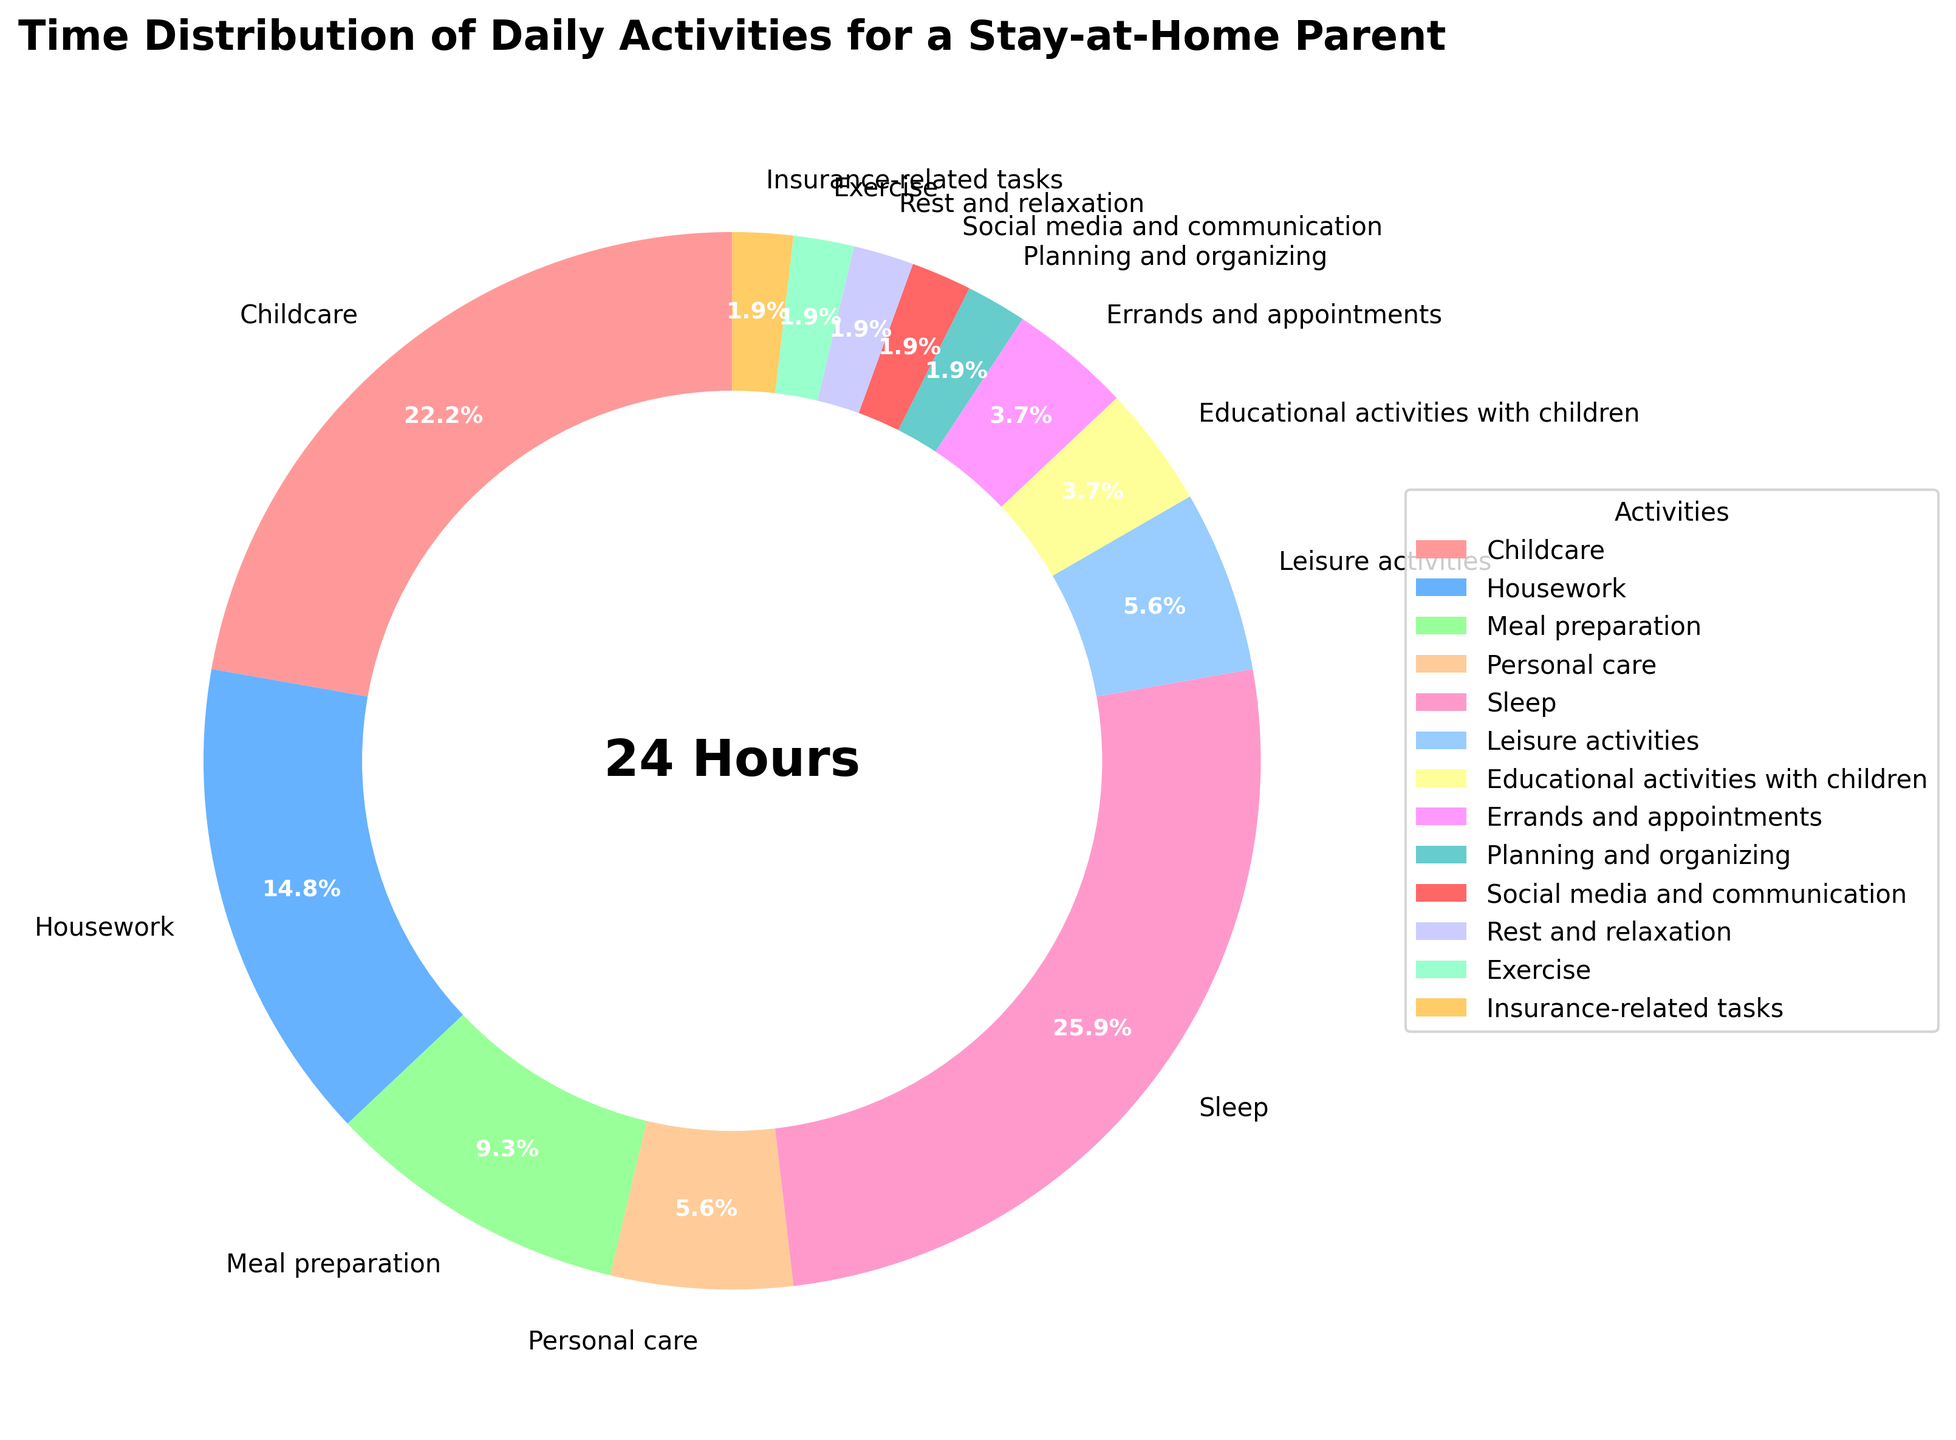which activity takes up the most hours in a day? The chart shows the percentage of time spent on each activity. The segment with the largest portion of the pie corresponds to the activity with the most hours. In this case, 'Sleep' occupies the most hours in a day.
Answer: Sleep what is the total time spent on housework and meal preparation? From the chart, 'Housework' takes 4 hours and 'Meal preparation' takes 2.5 hours. Adding these two values gives the total time spent on both activities. 4 hours + 2.5 hours = 6.5 hours
Answer: 6.5 hours which activity involves approximately 1 hour of daily time? By observing the segments of the pie chart, ‘Educational activities with children’ and 'Errands and appointments' each occupies approximately 1 hour.
Answer: Educational activities with children and Errands and appointments how much more time is spent on childcare compared to educational activities with children? The chart shows that 'Childcare' takes 6 hours and 'Educational activities with children' takes 1 hour. The difference is 6 hours - 1 hour = 5 hours.
Answer: 5 hours what is the percentage of the total day spent on sleep and leisure activities combined? From the chart, 'Sleep' accounts for 29.2% (7/24*100) and 'Leisure activities' account for 6.3% (1.5/24*100). Adding these percentages gives the total percentage of the day spent on both activities. 29.2% + 6.3% = 35.5%.
Answer: 35.5% which activities take the same amount of time daily? By examining the pie chart, 'Planning and organizing,' 'Social media and communication,' 'Rest and relaxation,' 'Exercise,' and 'Insurance-related tasks' each take 0.5 hours, meaning they all take the same amount of time daily.
Answer: Planning and organizing, Social media and communication, Rest and relaxation, Exercise, Insurance-related tasks how does the time spent on meal preparation compare to the time spent on housework? The chart shows that 'Meal preparation' takes 2.5 hours and 'Housework' takes 4 hours. Comparing these values, we see that more time is spent on housework than on meal preparation.
Answer: More time is spent on housework what fraction of the day is spent on personal care? Personal care takes 1.5 hours out of a 24-hour day. The fraction is 1.5/24 = 1/16.
Answer: 1/16 which activity has the smallest portion of the pie chart, and how much time does it represent? The smallest portion of the pie chart corresponds to 'Planning and organizing,' 'Social media and communication,' 'Rest and relaxation,' 'Exercise,', and 'Insurance-related tasks' each representing individual 0.5 hours.
Answer: 0.5 hours each 